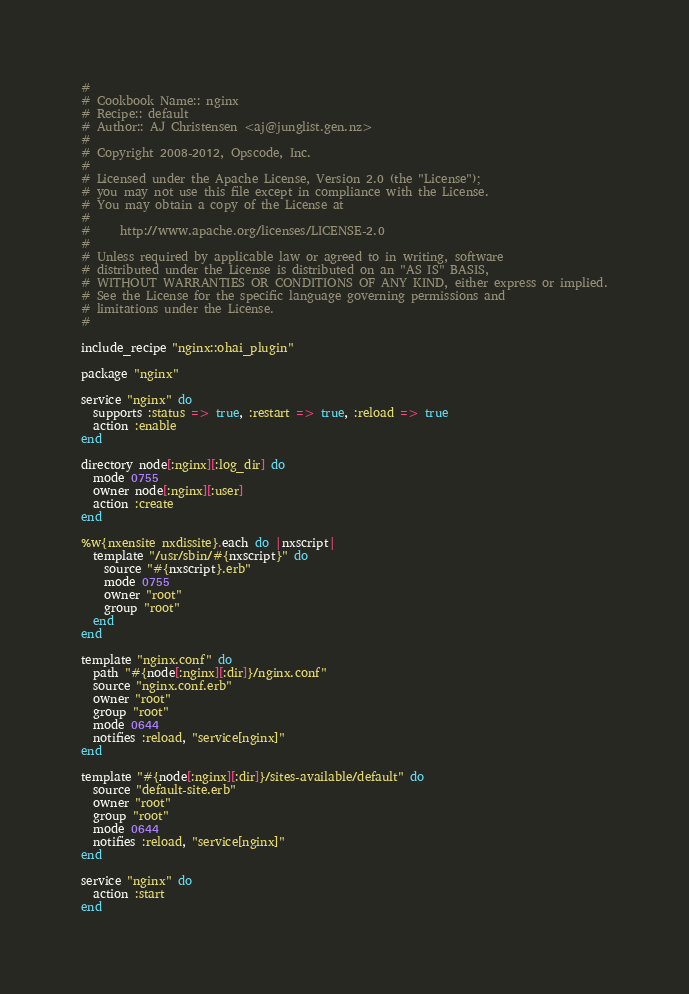<code> <loc_0><loc_0><loc_500><loc_500><_Ruby_>#
# Cookbook Name:: nginx
# Recipe:: default
# Author:: AJ Christensen <aj@junglist.gen.nz>
#
# Copyright 2008-2012, Opscode, Inc.
#
# Licensed under the Apache License, Version 2.0 (the "License");
# you may not use this file except in compliance with the License.
# You may obtain a copy of the License at
#
#     http://www.apache.org/licenses/LICENSE-2.0
#
# Unless required by applicable law or agreed to in writing, software
# distributed under the License is distributed on an "AS IS" BASIS,
# WITHOUT WARRANTIES OR CONDITIONS OF ANY KIND, either express or implied.
# See the License for the specific language governing permissions and
# limitations under the License.
#

include_recipe "nginx::ohai_plugin"

package "nginx"

service "nginx" do
  supports :status => true, :restart => true, :reload => true
  action :enable
end

directory node[:nginx][:log_dir] do
  mode 0755
  owner node[:nginx][:user]
  action :create
end

%w{nxensite nxdissite}.each do |nxscript|
  template "/usr/sbin/#{nxscript}" do
    source "#{nxscript}.erb"
    mode 0755
    owner "root"
    group "root"
  end
end

template "nginx.conf" do
  path "#{node[:nginx][:dir]}/nginx.conf"
  source "nginx.conf.erb"
  owner "root"
  group "root"
  mode 0644
  notifies :reload, "service[nginx]"
end

template "#{node[:nginx][:dir]}/sites-available/default" do
  source "default-site.erb"
  owner "root"
  group "root"
  mode 0644
  notifies :reload, "service[nginx]"
end

service "nginx" do
  action :start
end
</code> 